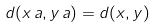<formula> <loc_0><loc_0><loc_500><loc_500>d ( x \, a , y \, a ) = d ( x , y )</formula> 